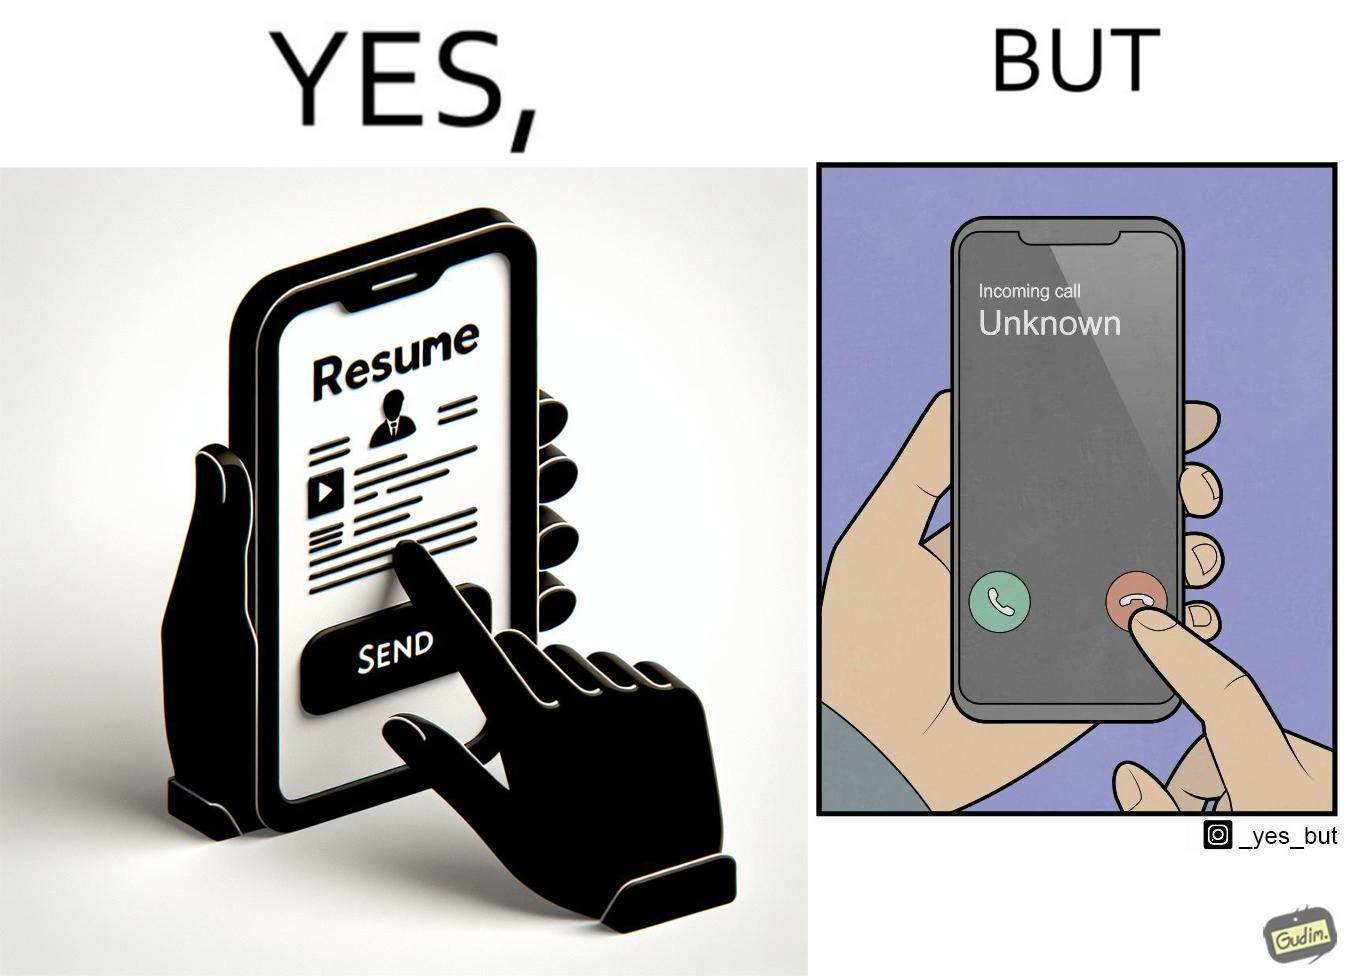Describe the content of this image. The image is ironic, because on the left image the person is sending their resume to someone and on the right they are rejecting the unknown calls which might be some offer calls  or the person who sent the resume maybe tired of the spam calls after sending the resume which he sent seeking some new oppurtunities 